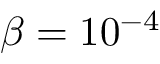<formula> <loc_0><loc_0><loc_500><loc_500>\beta = 1 0 ^ { - 4 }</formula> 